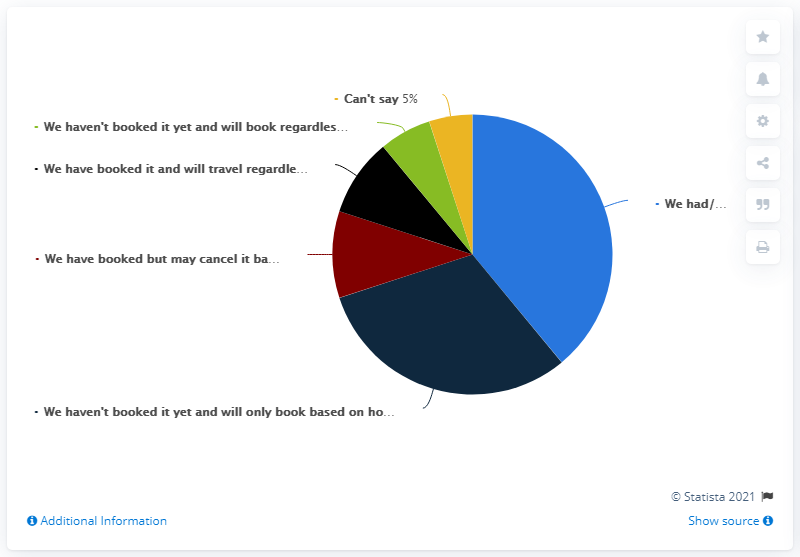List a handful of essential elements in this visual. According to the survey, 31% of Indian respondents stated that they had not made any travel bookings. A significant percentage of people are unable to say the number 5. There are six categories indicated in the graph. 